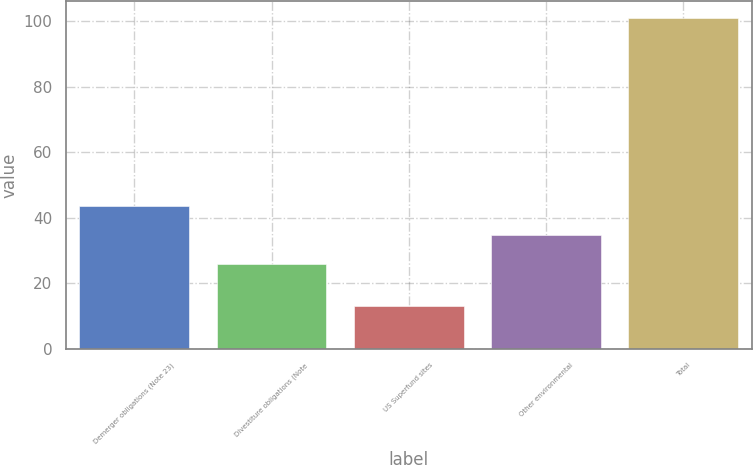Convert chart. <chart><loc_0><loc_0><loc_500><loc_500><bar_chart><fcel>Demerger obligations (Note 23)<fcel>Divestiture obligations (Note<fcel>US Superfund sites<fcel>Other environmental<fcel>Total<nl><fcel>43.6<fcel>26<fcel>13<fcel>34.8<fcel>101<nl></chart> 